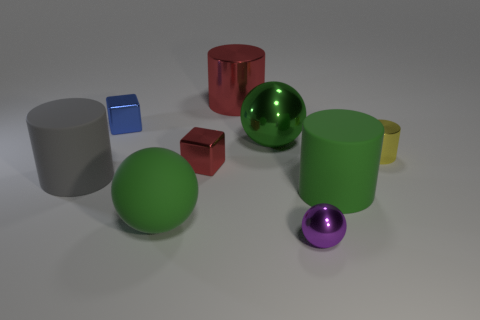How many green balls must be subtracted to get 1 green balls? 1 Subtract all cyan cubes. How many green balls are left? 2 Subtract 1 balls. How many balls are left? 2 Subtract all metal balls. How many balls are left? 1 Subtract all gray cylinders. How many cylinders are left? 3 Subtract all blue cylinders. Subtract all green cubes. How many cylinders are left? 4 Add 1 big cyan things. How many objects exist? 10 Subtract all spheres. How many objects are left? 6 Add 1 tiny purple metal spheres. How many tiny purple metal spheres exist? 2 Subtract 0 purple cylinders. How many objects are left? 9 